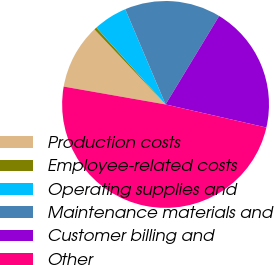Convert chart. <chart><loc_0><loc_0><loc_500><loc_500><pie_chart><fcel>Production costs<fcel>Employee-related costs<fcel>Operating supplies and<fcel>Maintenance materials and<fcel>Customer billing and<fcel>Other<nl><fcel>10.16%<fcel>0.41%<fcel>5.29%<fcel>15.04%<fcel>19.92%<fcel>49.18%<nl></chart> 